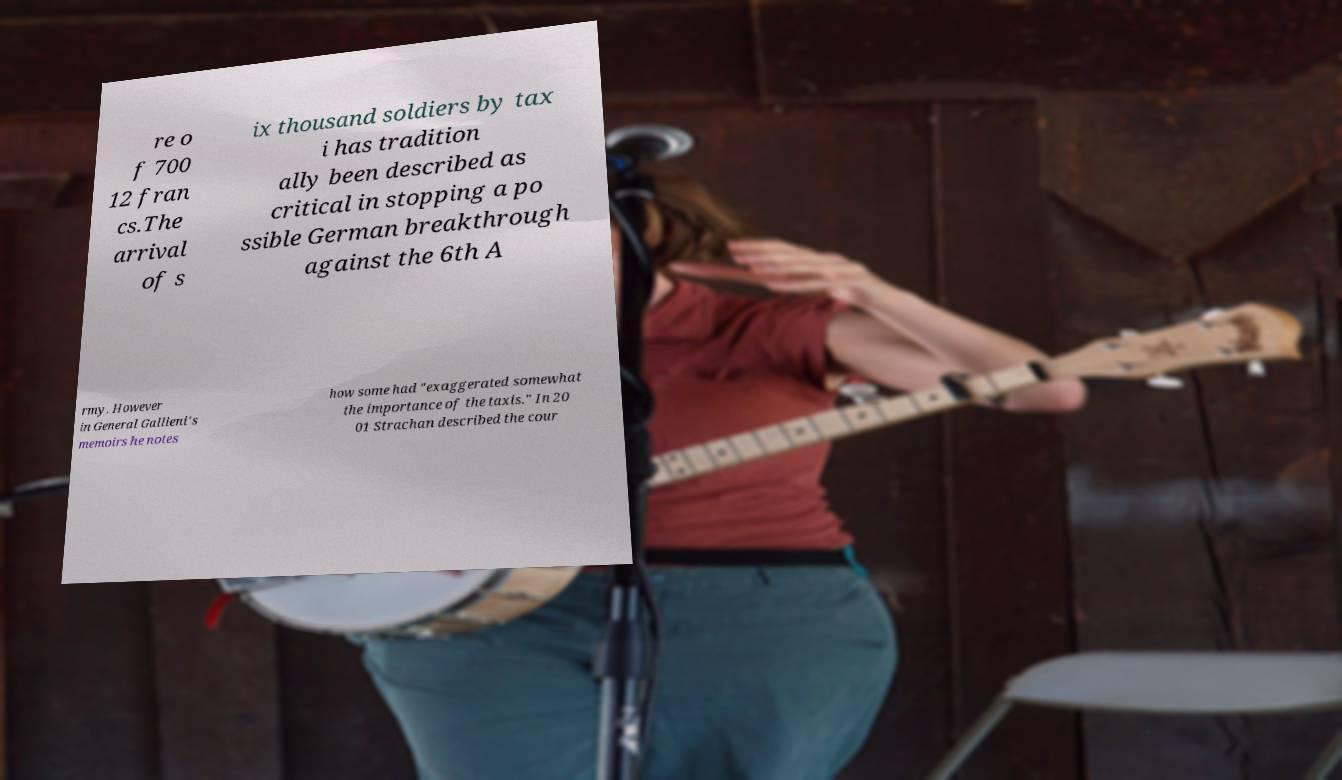What messages or text are displayed in this image? I need them in a readable, typed format. re o f 700 12 fran cs.The arrival of s ix thousand soldiers by tax i has tradition ally been described as critical in stopping a po ssible German breakthrough against the 6th A rmy. However in General Gallieni's memoirs he notes how some had "exaggerated somewhat the importance of the taxis." In 20 01 Strachan described the cour 